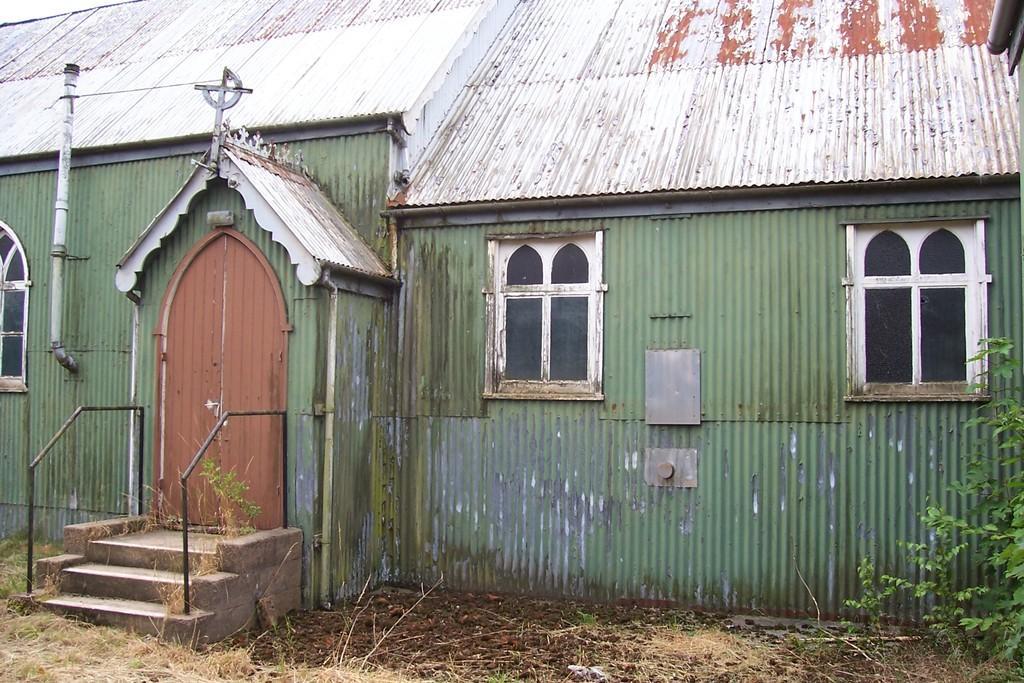Please provide a concise description of this image. In this image we can see a shed. On the left there are stairs and we can see railings. On the right there is a tree and we can see a door and windows. 